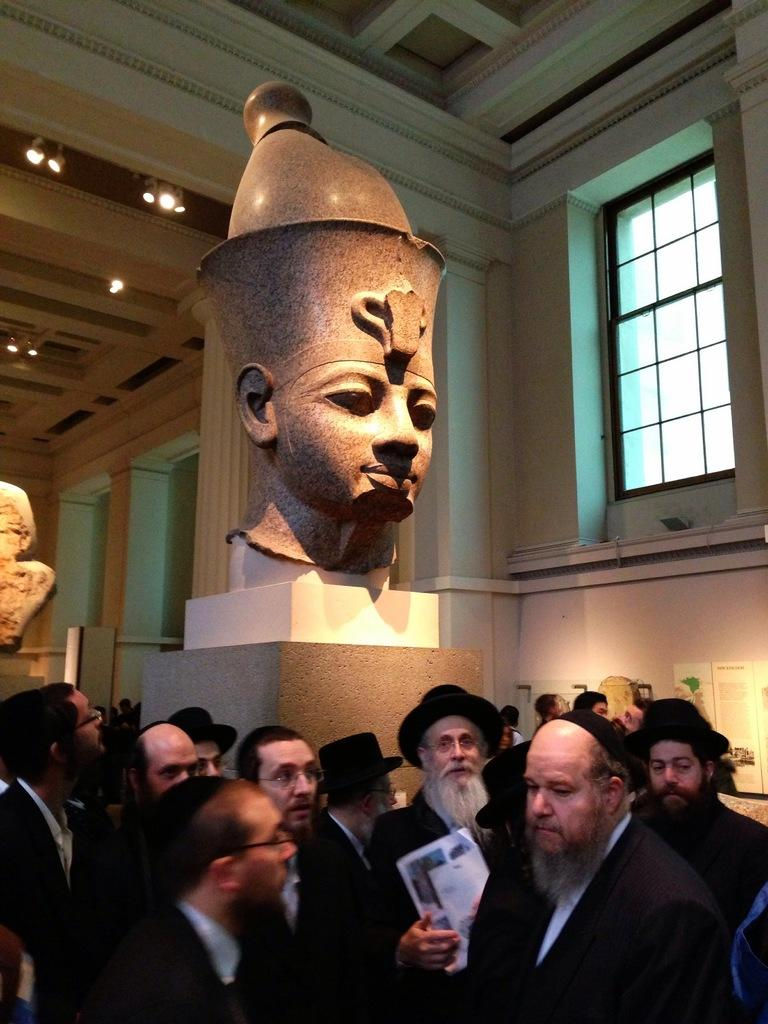What can be seen in the image involving multiple individuals? There is a group of people in the image. What is located on the wall in the image? There is a statue on the wall in the image. What is visible at the top of the image? There are lights visible at the top of the image. How many laborers are carrying the basin in the image? There is no basin or laborers present in the image. What type of lift is being used by the group of people in the image? There is no lift present in the image. 